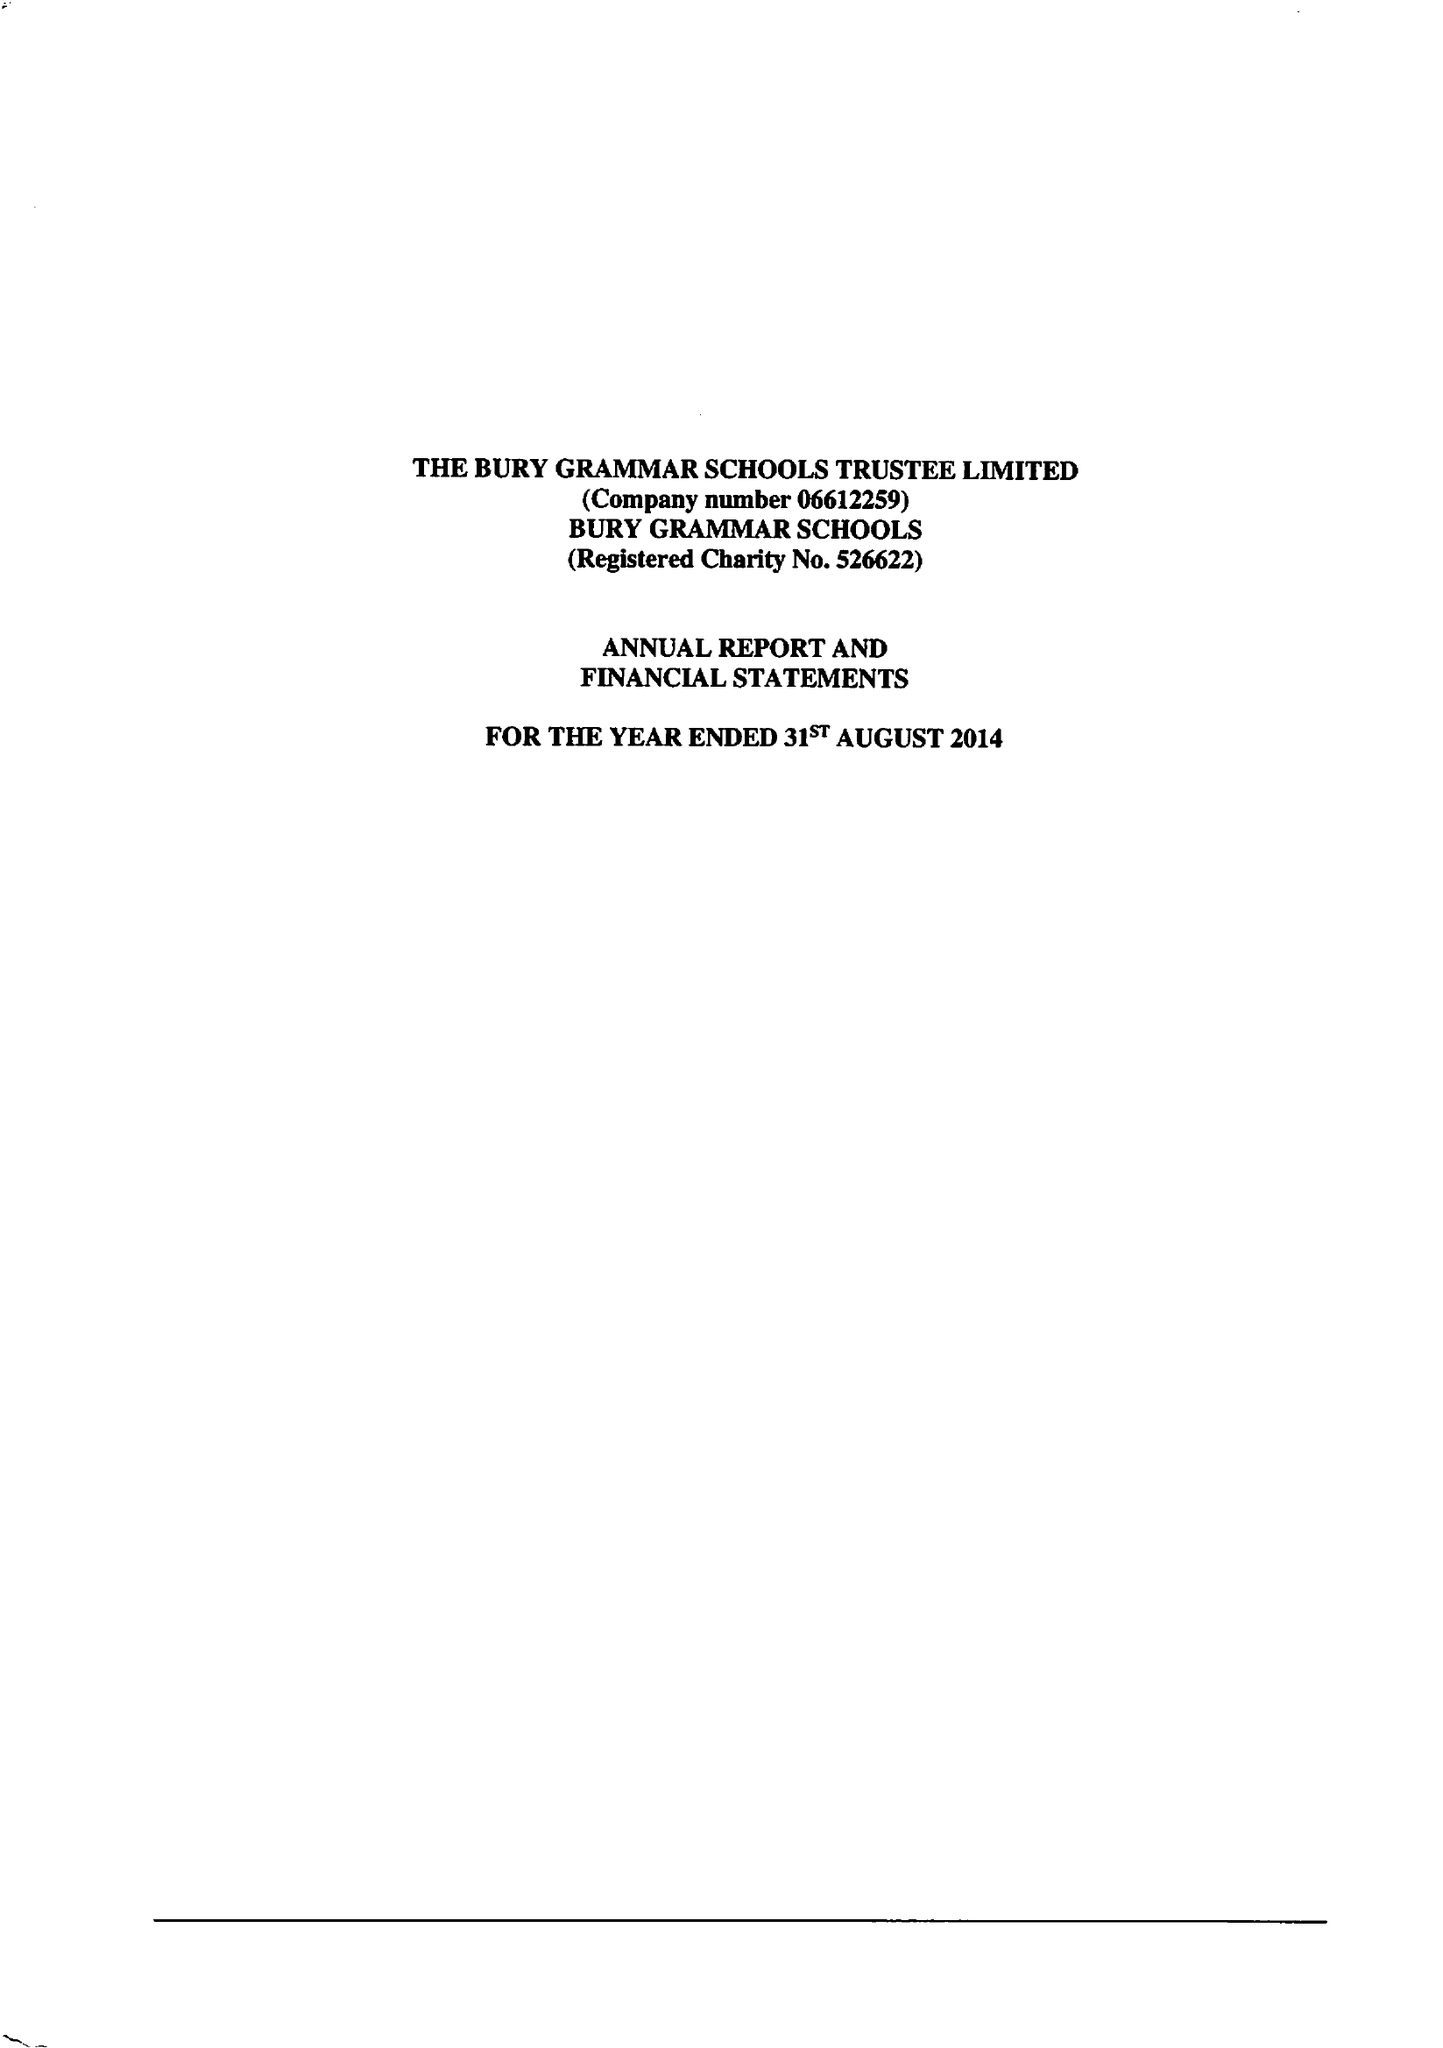What is the value for the income_annually_in_british_pounds?
Answer the question using a single word or phrase. 13109000.00 